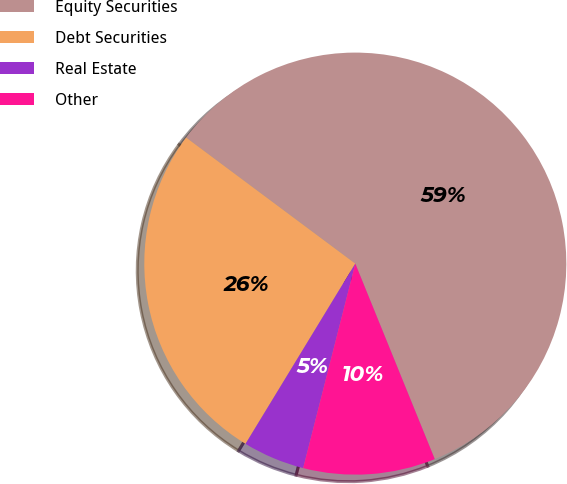Convert chart to OTSL. <chart><loc_0><loc_0><loc_500><loc_500><pie_chart><fcel>Equity Securities<fcel>Debt Securities<fcel>Real Estate<fcel>Other<nl><fcel>58.66%<fcel>26.49%<fcel>4.73%<fcel>10.12%<nl></chart> 